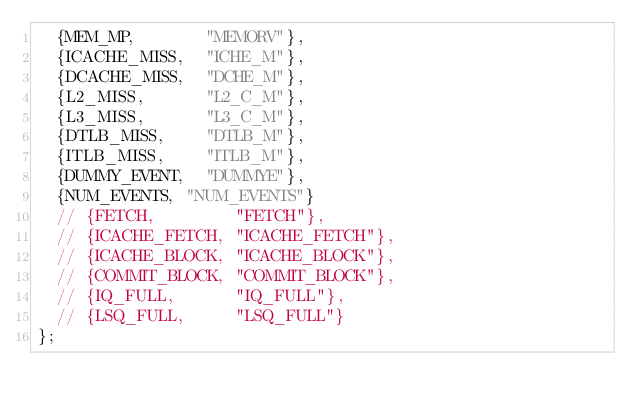<code> <loc_0><loc_0><loc_500><loc_500><_C++_>  {MEM_MP,       "MEMORV"},
  {ICACHE_MISS,  "ICHE_M"},
  {DCACHE_MISS,  "DCHE_M"},
  {L2_MISS,      "L2_C_M"},
  {L3_MISS,      "L3_C_M"},
  {DTLB_MISS,    "DTLB_M"},
  {ITLB_MISS,    "ITLB_M"},
  {DUMMY_EVENT,  "DUMMYE"},
  {NUM_EVENTS, "NUM_EVENTS"}
  // {FETCH,        "FETCH"},
  // {ICACHE_FETCH, "ICACHE_FETCH"},
  // {ICACHE_BLOCK, "ICACHE_BLOCK"},
  // {COMMIT_BLOCK, "COMMIT_BLOCK"},
  // {IQ_FULL,      "IQ_FULL"},
  // {LSQ_FULL,     "LSQ_FULL"}
};
</code> 